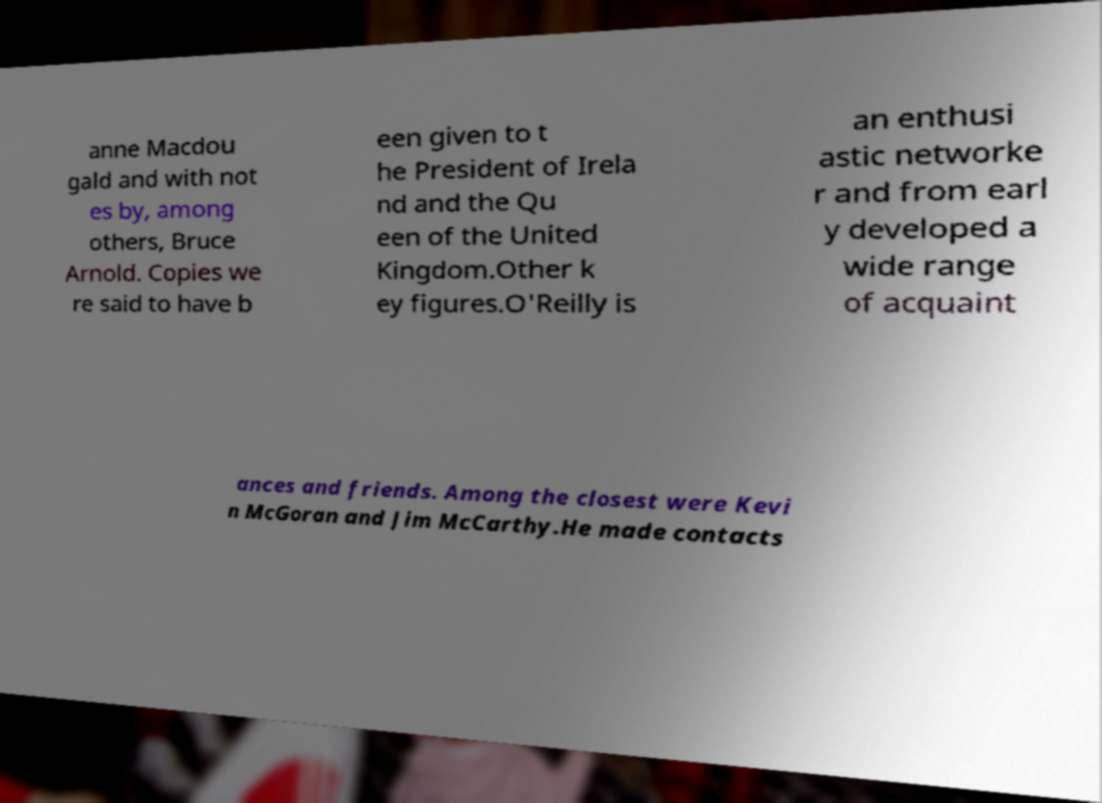Please read and relay the text visible in this image. What does it say? anne Macdou gald and with not es by, among others, Bruce Arnold. Copies we re said to have b een given to t he President of Irela nd and the Qu een of the United Kingdom.Other k ey figures.O'Reilly is an enthusi astic networke r and from earl y developed a wide range of acquaint ances and friends. Among the closest were Kevi n McGoran and Jim McCarthy.He made contacts 